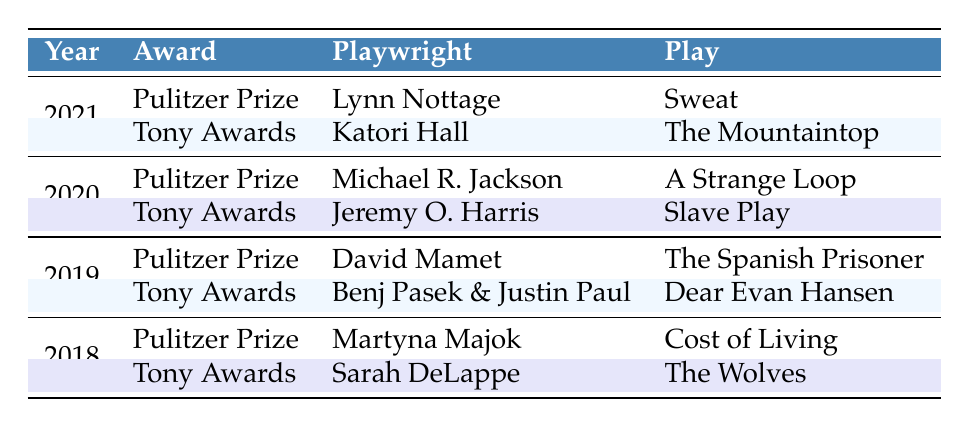What playwright won the Pulitzer Prize in 2021? The table shows that the Pulitzer Prize for 2021 was awarded to Lynn Nottage for her play "Sweat."
Answer: Lynn Nottage Which play won the Tony Award in 2020? According to the table, the Tony Award for 2020 was awarded to Jeremy O. Harris for his play "Slave Play."
Answer: Slave Play Did David Mamet win a Pulitzer Prize for a play in 2019? The table indicates that David Mamet won the Pulitzer Prize in 2019 for his play "The Spanish Prisoner," so the answer is yes.
Answer: Yes What is the difference in the number of years between the Pulitzer Prize winners of 2018 and 2021? The years are 2018 and 2021. The difference between these two years is 2021 - 2018 = 3 years.
Answer: 3 Which playwrights won awards in the same year? From the table, two playwrights won awards in 2021: Lynn Nottage (Pulitzer Prize) and Katori Hall (Tony Awards). The same is true for 2020, where Michael R. Jackson and Jeremy O. Harris won awards.
Answer: 2021: Lynn Nottage, Katori Hall; 2020: Michael R. Jackson, Jeremy O. Harris Who won both the Tony Award and the Pulitzer Prize in the same year? The table shows that there are no playwrights who won both the Tony Award and the Pulitzer Prize in the same year.
Answer: No What is the latest year in which a Pulitzer Prize was awarded, and who was the playwright? The most recent year listed for the Pulitzer Prize is 2021, with Lynn Nottage being the playwright for the play "Sweat."
Answer: 2021, Lynn Nottage How many different playwrights have won the Pulitzer Prize from 2018 to 2021? The Pulitzer Prize winners listed in the table from 2018 to 2021 are Lynn Nottage, Michael R. Jackson, David Mamet, and Martyna Majok, totaling 4 different playwrights.
Answer: 4 What was the play for which Katori Hall won the Tony Award? The table specifies that Katori Hall won the Tony Award in 2021 for her play "The Mountaintop."
Answer: The Mountaintop 